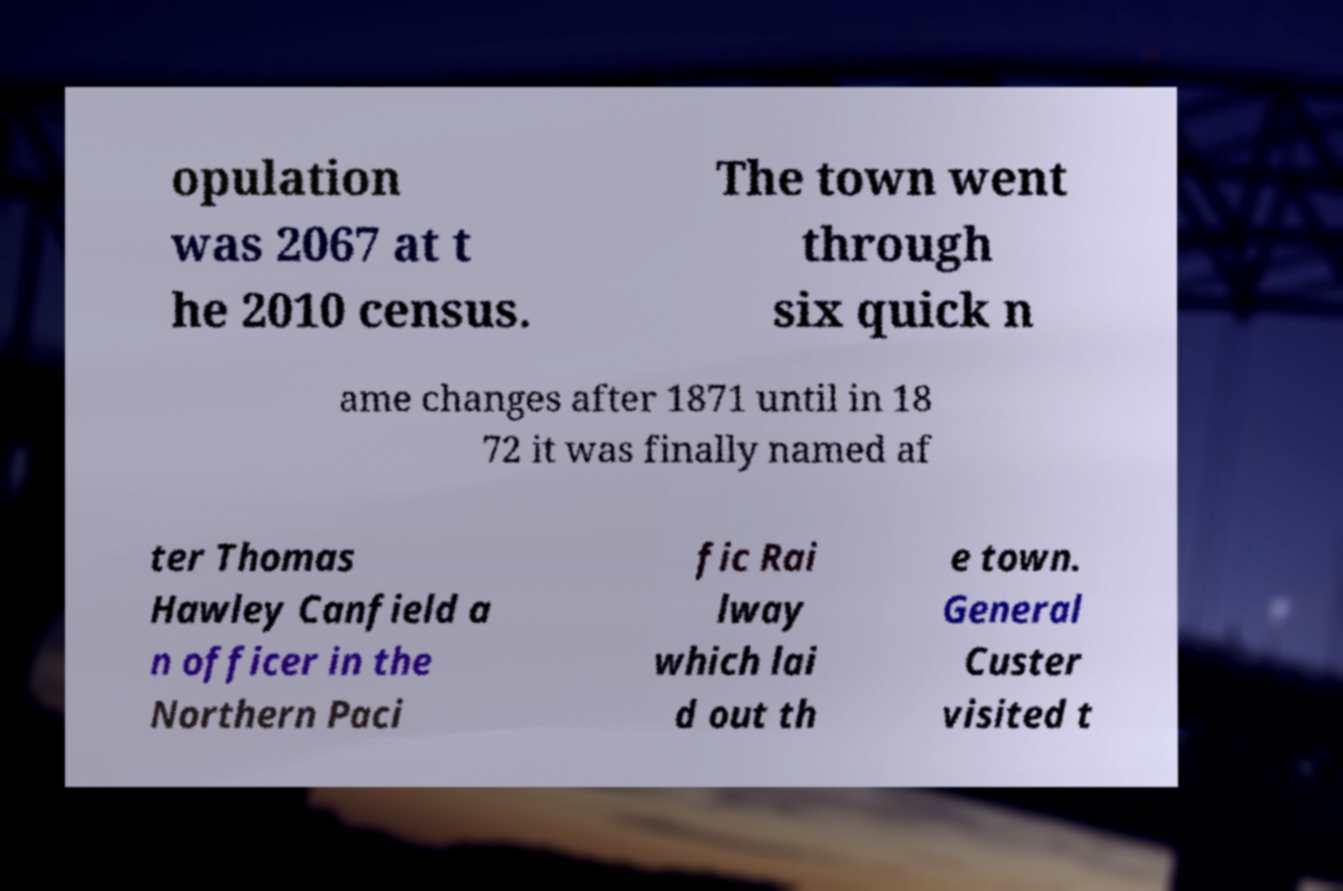I need the written content from this picture converted into text. Can you do that? opulation was 2067 at t he 2010 census. The town went through six quick n ame changes after 1871 until in 18 72 it was finally named af ter Thomas Hawley Canfield a n officer in the Northern Paci fic Rai lway which lai d out th e town. General Custer visited t 